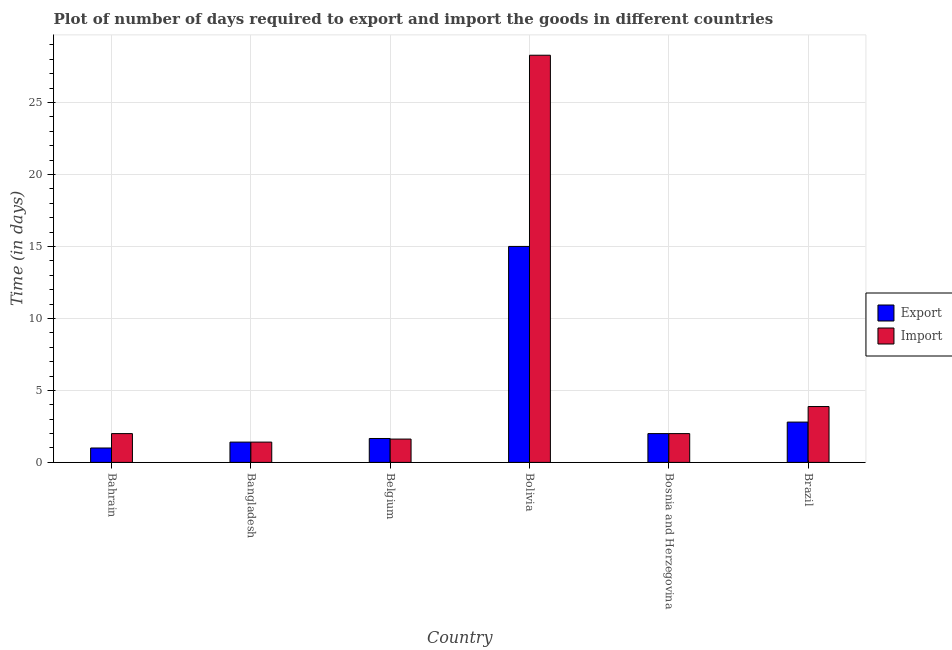How many different coloured bars are there?
Offer a very short reply. 2. How many bars are there on the 4th tick from the left?
Your response must be concise. 2. How many bars are there on the 5th tick from the right?
Your answer should be very brief. 2. What is the label of the 4th group of bars from the left?
Give a very brief answer. Bolivia. In how many cases, is the number of bars for a given country not equal to the number of legend labels?
Provide a short and direct response. 0. What is the time required to import in Belgium?
Ensure brevity in your answer.  1.62. Across all countries, what is the minimum time required to import?
Ensure brevity in your answer.  1.41. In which country was the time required to export maximum?
Your answer should be very brief. Bolivia. In which country was the time required to import minimum?
Make the answer very short. Bangladesh. What is the total time required to export in the graph?
Offer a very short reply. 23.87. What is the difference between the time required to export in Belgium and that in Bolivia?
Your answer should be compact. -13.34. What is the difference between the time required to import in Bangladesh and the time required to export in Bolivia?
Offer a very short reply. -13.59. What is the average time required to export per country?
Your response must be concise. 3.98. What is the difference between the time required to import and time required to export in Bahrain?
Your answer should be compact. 1. In how many countries, is the time required to import greater than 3 days?
Give a very brief answer. 2. What is the ratio of the time required to import in Bangladesh to that in Bolivia?
Ensure brevity in your answer.  0.05. What is the difference between the highest and the second highest time required to export?
Make the answer very short. 12.2. In how many countries, is the time required to export greater than the average time required to export taken over all countries?
Provide a succinct answer. 1. What does the 2nd bar from the left in Bahrain represents?
Your answer should be very brief. Import. What does the 2nd bar from the right in Bosnia and Herzegovina represents?
Your answer should be compact. Export. How many bars are there?
Provide a short and direct response. 12. Are all the bars in the graph horizontal?
Ensure brevity in your answer.  No. How many countries are there in the graph?
Your response must be concise. 6. What is the difference between two consecutive major ticks on the Y-axis?
Your response must be concise. 5. Does the graph contain any zero values?
Offer a terse response. No. Does the graph contain grids?
Your response must be concise. Yes. Where does the legend appear in the graph?
Offer a very short reply. Center right. How many legend labels are there?
Provide a short and direct response. 2. How are the legend labels stacked?
Your answer should be very brief. Vertical. What is the title of the graph?
Provide a succinct answer. Plot of number of days required to export and import the goods in different countries. What is the label or title of the X-axis?
Your answer should be very brief. Country. What is the label or title of the Y-axis?
Offer a terse response. Time (in days). What is the Time (in days) of Export in Bahrain?
Offer a terse response. 1. What is the Time (in days) in Export in Bangladesh?
Your response must be concise. 1.41. What is the Time (in days) in Import in Bangladesh?
Provide a succinct answer. 1.41. What is the Time (in days) of Export in Belgium?
Provide a short and direct response. 1.66. What is the Time (in days) of Import in Belgium?
Make the answer very short. 1.62. What is the Time (in days) of Import in Bolivia?
Give a very brief answer. 28.28. What is the Time (in days) of Export in Bosnia and Herzegovina?
Offer a terse response. 2. What is the Time (in days) in Import in Brazil?
Give a very brief answer. 3.88. Across all countries, what is the maximum Time (in days) in Import?
Your answer should be compact. 28.28. Across all countries, what is the minimum Time (in days) of Export?
Provide a short and direct response. 1. Across all countries, what is the minimum Time (in days) in Import?
Your answer should be compact. 1.41. What is the total Time (in days) in Export in the graph?
Ensure brevity in your answer.  23.87. What is the total Time (in days) in Import in the graph?
Make the answer very short. 39.19. What is the difference between the Time (in days) of Export in Bahrain and that in Bangladesh?
Provide a succinct answer. -0.41. What is the difference between the Time (in days) of Import in Bahrain and that in Bangladesh?
Your answer should be compact. 0.59. What is the difference between the Time (in days) of Export in Bahrain and that in Belgium?
Provide a short and direct response. -0.66. What is the difference between the Time (in days) in Import in Bahrain and that in Belgium?
Ensure brevity in your answer.  0.38. What is the difference between the Time (in days) of Export in Bahrain and that in Bolivia?
Give a very brief answer. -14. What is the difference between the Time (in days) of Import in Bahrain and that in Bolivia?
Provide a succinct answer. -26.28. What is the difference between the Time (in days) in Export in Bahrain and that in Brazil?
Offer a terse response. -1.8. What is the difference between the Time (in days) in Import in Bahrain and that in Brazil?
Ensure brevity in your answer.  -1.88. What is the difference between the Time (in days) in Import in Bangladesh and that in Belgium?
Your answer should be compact. -0.21. What is the difference between the Time (in days) in Export in Bangladesh and that in Bolivia?
Offer a very short reply. -13.59. What is the difference between the Time (in days) of Import in Bangladesh and that in Bolivia?
Provide a short and direct response. -26.87. What is the difference between the Time (in days) in Export in Bangladesh and that in Bosnia and Herzegovina?
Offer a very short reply. -0.59. What is the difference between the Time (in days) in Import in Bangladesh and that in Bosnia and Herzegovina?
Offer a very short reply. -0.59. What is the difference between the Time (in days) of Export in Bangladesh and that in Brazil?
Offer a very short reply. -1.39. What is the difference between the Time (in days) of Import in Bangladesh and that in Brazil?
Keep it short and to the point. -2.47. What is the difference between the Time (in days) of Export in Belgium and that in Bolivia?
Your answer should be compact. -13.34. What is the difference between the Time (in days) of Import in Belgium and that in Bolivia?
Your response must be concise. -26.66. What is the difference between the Time (in days) of Export in Belgium and that in Bosnia and Herzegovina?
Keep it short and to the point. -0.34. What is the difference between the Time (in days) of Import in Belgium and that in Bosnia and Herzegovina?
Your answer should be compact. -0.38. What is the difference between the Time (in days) in Export in Belgium and that in Brazil?
Make the answer very short. -1.14. What is the difference between the Time (in days) of Import in Belgium and that in Brazil?
Offer a terse response. -2.26. What is the difference between the Time (in days) of Import in Bolivia and that in Bosnia and Herzegovina?
Your answer should be very brief. 26.28. What is the difference between the Time (in days) in Import in Bolivia and that in Brazil?
Offer a very short reply. 24.4. What is the difference between the Time (in days) in Export in Bosnia and Herzegovina and that in Brazil?
Provide a short and direct response. -0.8. What is the difference between the Time (in days) of Import in Bosnia and Herzegovina and that in Brazil?
Offer a very short reply. -1.88. What is the difference between the Time (in days) in Export in Bahrain and the Time (in days) in Import in Bangladesh?
Your answer should be very brief. -0.41. What is the difference between the Time (in days) of Export in Bahrain and the Time (in days) of Import in Belgium?
Give a very brief answer. -0.62. What is the difference between the Time (in days) of Export in Bahrain and the Time (in days) of Import in Bolivia?
Your response must be concise. -27.28. What is the difference between the Time (in days) of Export in Bahrain and the Time (in days) of Import in Bosnia and Herzegovina?
Provide a succinct answer. -1. What is the difference between the Time (in days) of Export in Bahrain and the Time (in days) of Import in Brazil?
Your response must be concise. -2.88. What is the difference between the Time (in days) in Export in Bangladesh and the Time (in days) in Import in Belgium?
Provide a succinct answer. -0.21. What is the difference between the Time (in days) in Export in Bangladesh and the Time (in days) in Import in Bolivia?
Your answer should be compact. -26.87. What is the difference between the Time (in days) of Export in Bangladesh and the Time (in days) of Import in Bosnia and Herzegovina?
Your response must be concise. -0.59. What is the difference between the Time (in days) of Export in Bangladesh and the Time (in days) of Import in Brazil?
Your answer should be very brief. -2.47. What is the difference between the Time (in days) in Export in Belgium and the Time (in days) in Import in Bolivia?
Make the answer very short. -26.62. What is the difference between the Time (in days) of Export in Belgium and the Time (in days) of Import in Bosnia and Herzegovina?
Your response must be concise. -0.34. What is the difference between the Time (in days) in Export in Belgium and the Time (in days) in Import in Brazil?
Make the answer very short. -2.22. What is the difference between the Time (in days) of Export in Bolivia and the Time (in days) of Import in Bosnia and Herzegovina?
Make the answer very short. 13. What is the difference between the Time (in days) in Export in Bolivia and the Time (in days) in Import in Brazil?
Provide a short and direct response. 11.12. What is the difference between the Time (in days) of Export in Bosnia and Herzegovina and the Time (in days) of Import in Brazil?
Your answer should be very brief. -1.88. What is the average Time (in days) in Export per country?
Make the answer very short. 3.98. What is the average Time (in days) in Import per country?
Your answer should be compact. 6.53. What is the difference between the Time (in days) in Export and Time (in days) in Import in Bolivia?
Keep it short and to the point. -13.28. What is the difference between the Time (in days) in Export and Time (in days) in Import in Bosnia and Herzegovina?
Provide a succinct answer. 0. What is the difference between the Time (in days) in Export and Time (in days) in Import in Brazil?
Keep it short and to the point. -1.08. What is the ratio of the Time (in days) in Export in Bahrain to that in Bangladesh?
Offer a terse response. 0.71. What is the ratio of the Time (in days) in Import in Bahrain to that in Bangladesh?
Make the answer very short. 1.42. What is the ratio of the Time (in days) in Export in Bahrain to that in Belgium?
Give a very brief answer. 0.6. What is the ratio of the Time (in days) in Import in Bahrain to that in Belgium?
Offer a very short reply. 1.23. What is the ratio of the Time (in days) in Export in Bahrain to that in Bolivia?
Provide a short and direct response. 0.07. What is the ratio of the Time (in days) of Import in Bahrain to that in Bolivia?
Keep it short and to the point. 0.07. What is the ratio of the Time (in days) of Import in Bahrain to that in Bosnia and Herzegovina?
Offer a terse response. 1. What is the ratio of the Time (in days) of Export in Bahrain to that in Brazil?
Offer a very short reply. 0.36. What is the ratio of the Time (in days) of Import in Bahrain to that in Brazil?
Offer a very short reply. 0.52. What is the ratio of the Time (in days) in Export in Bangladesh to that in Belgium?
Provide a short and direct response. 0.85. What is the ratio of the Time (in days) in Import in Bangladesh to that in Belgium?
Keep it short and to the point. 0.87. What is the ratio of the Time (in days) of Export in Bangladesh to that in Bolivia?
Offer a very short reply. 0.09. What is the ratio of the Time (in days) of Import in Bangladesh to that in Bolivia?
Your response must be concise. 0.05. What is the ratio of the Time (in days) in Export in Bangladesh to that in Bosnia and Herzegovina?
Offer a very short reply. 0.7. What is the ratio of the Time (in days) in Import in Bangladesh to that in Bosnia and Herzegovina?
Give a very brief answer. 0.7. What is the ratio of the Time (in days) of Export in Bangladesh to that in Brazil?
Make the answer very short. 0.5. What is the ratio of the Time (in days) in Import in Bangladesh to that in Brazil?
Keep it short and to the point. 0.36. What is the ratio of the Time (in days) of Export in Belgium to that in Bolivia?
Ensure brevity in your answer.  0.11. What is the ratio of the Time (in days) in Import in Belgium to that in Bolivia?
Keep it short and to the point. 0.06. What is the ratio of the Time (in days) in Export in Belgium to that in Bosnia and Herzegovina?
Offer a very short reply. 0.83. What is the ratio of the Time (in days) in Import in Belgium to that in Bosnia and Herzegovina?
Your answer should be very brief. 0.81. What is the ratio of the Time (in days) of Export in Belgium to that in Brazil?
Keep it short and to the point. 0.59. What is the ratio of the Time (in days) of Import in Belgium to that in Brazil?
Provide a succinct answer. 0.42. What is the ratio of the Time (in days) of Export in Bolivia to that in Bosnia and Herzegovina?
Your answer should be compact. 7.5. What is the ratio of the Time (in days) in Import in Bolivia to that in Bosnia and Herzegovina?
Keep it short and to the point. 14.14. What is the ratio of the Time (in days) in Export in Bolivia to that in Brazil?
Offer a very short reply. 5.36. What is the ratio of the Time (in days) in Import in Bolivia to that in Brazil?
Offer a terse response. 7.29. What is the ratio of the Time (in days) in Import in Bosnia and Herzegovina to that in Brazil?
Your answer should be compact. 0.52. What is the difference between the highest and the second highest Time (in days) of Export?
Keep it short and to the point. 12.2. What is the difference between the highest and the second highest Time (in days) in Import?
Your answer should be very brief. 24.4. What is the difference between the highest and the lowest Time (in days) of Import?
Ensure brevity in your answer.  26.87. 